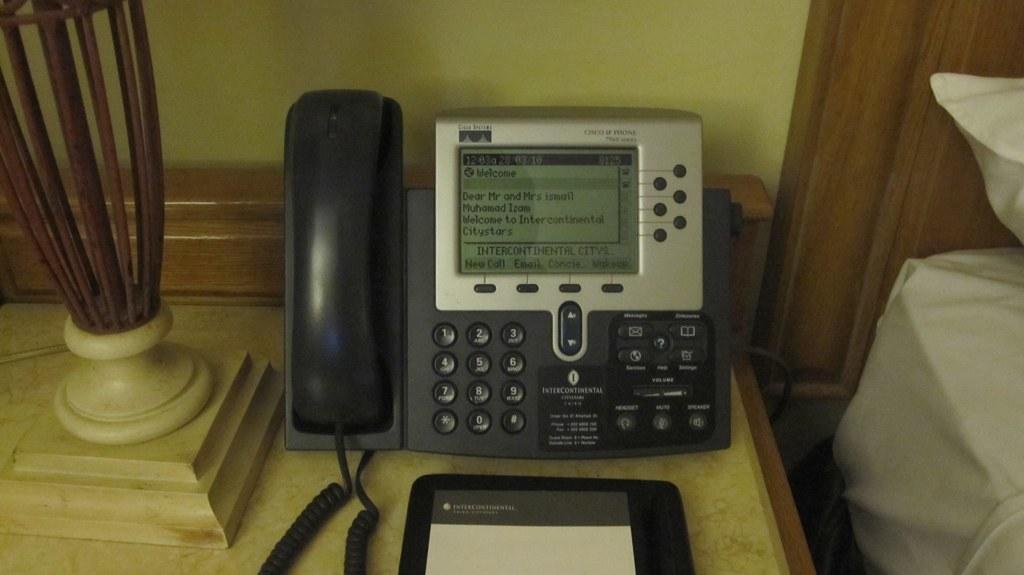How would you summarize this image in a sentence or two? In this image we can see a telephone with numbers and text placed on the table. In the foreground we can see a file. To the left side, we can see a sculpture. To the right side, we can see a pillow and in the background, we can see a cupboard and the wall. 